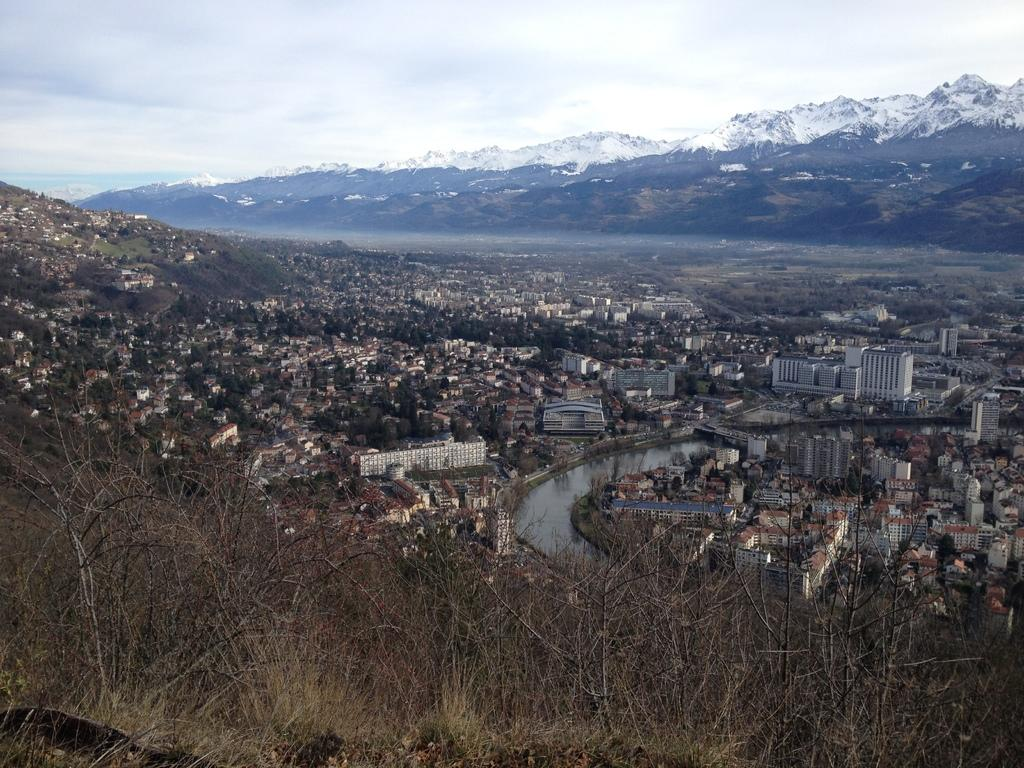What type of structures can be seen in the image? There are buildings in the image. What natural elements are present in the image? There are trees and water visible in the image. What can be seen in the distance in the image? There is a mountain in the background of the image. What is visible in the sky in the image? The sky is visible in the background of the image. How does the thumb affect the rainstorm in the image? There is no thumb or rainstorm present in the image. 